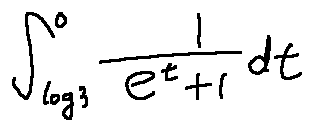Convert formula to latex. <formula><loc_0><loc_0><loc_500><loc_500>\int \lim i t s _ { \log 3 } ^ { 0 } \frac { 1 } { e ^ { t } + 1 } d t</formula> 